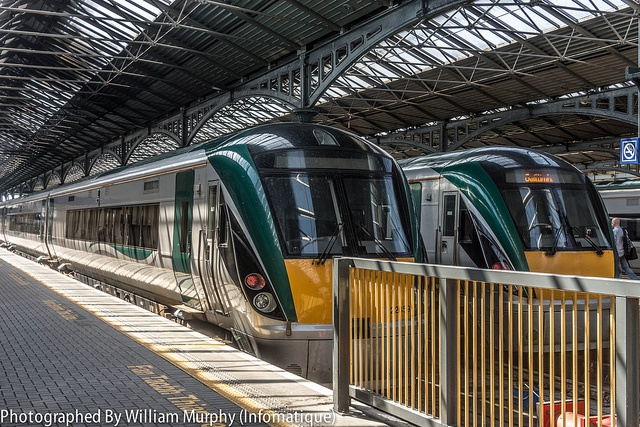Describe the objects in this image and their specific colors. I can see train in gray, black, darkgray, and lightgray tones, train in gray, black, olive, and darkgray tones, people in gray and black tones, and backpack in gray and black tones in this image. 